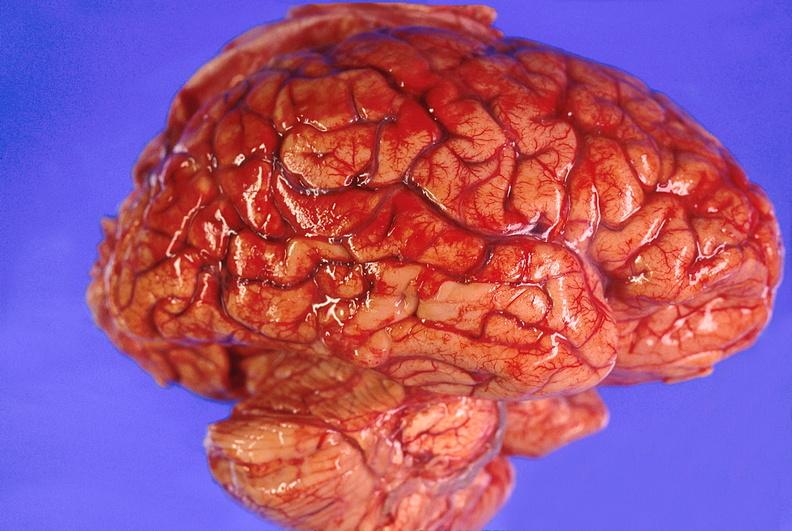what is present?
Answer the question using a single word or phrase. Nervous 